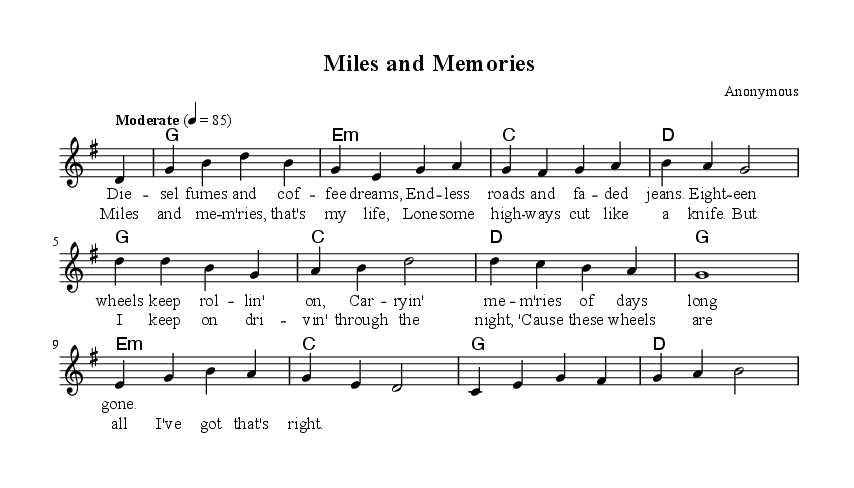What is the key signature of this music? The key signature is G major, which has one sharp (F#). This can be determined by looking at the clef at the beginning of the staff, where the sharp is indicated.
Answer: G major What is the time signature of this music? The time signature is four-four, as indicated by the fraction shown at the beginning of the score, which suggests there are four beats in each measure.
Answer: Four-four What is the tempo marking for this piece? The tempo marking is "Moderate" with a beat of 85, which can be identified where the tempo indication is noted in the score.
Answer: Moderate, 4 = 85 How many measures are in the melody? The melody consists of five measures, which can be counted by looking at the vertical bar lines dividing the notes.
Answer: Five measures What is the first lyric in the verse? The first lyric in the verse is "Diesel," as found in the line of lyrics that follows the melody. This lyric starts at the beginning of the verse.
Answer: Diesel What is the mood conveyed by the lyrics of the song? The mood conveyed by the lyrics reflects a sense of nostalgia and loneliness, which can be inferred from the themes of memories and long distances present in the text.
Answer: Nostalgia and loneliness How does the chorus relate to the verse? The chorus encapsulates the essence of the verse by summarizing the trucker's life and emotional journey, reinforcing the themes of loneliness and perseverance. This relationship is typical in song structures, providing a contrast or reflection.
Answer: Summary of life's journey 